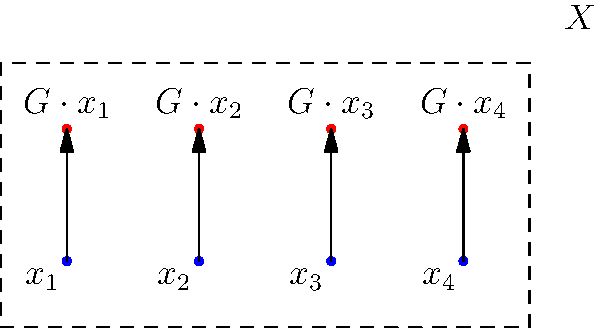Consider a group $G$ acting on a set $X = \{x_1, x_2, x_3, x_4\}$. The diagram illustrates the orbits of each element under this group action. If the stabilizer of $x_2$ has order 3, what is the order of the group $G$, assuming the orbit-stabilizer theorem holds? Let's approach this step-by-step using the orbit-stabilizer theorem:

1) The orbit-stabilizer theorem states that for a group $G$ acting on a set $X$, and for any $x \in X$:

   $|G| = |G \cdot x| \cdot |G_x|$

   where $|G \cdot x|$ is the size of the orbit of $x$, and $|G_x|$ is the size of the stabilizer of $x$.

2) We're given that the stabilizer of $x_2$ has order 3, so $|G_{x_2}| = 3$.

3) From the diagram, we can see that each element has its own orbit, so the orbit of $x_2$ contains only one element. Thus, $|G \cdot x_2| = 1$.

4) Applying the orbit-stabilizer theorem to $x_2$:

   $|G| = |G \cdot x_2| \cdot |G_{x_2}| = 1 \cdot 3 = 3$

5) We can verify this result by checking it against the other elements:
   - Each element has an orbit of size 1
   - This means each element must have a stabilizer of size 3 (the whole group)
   - This is consistent with the group having order 3

Therefore, the order of the group $G$ is 3.
Answer: 3 